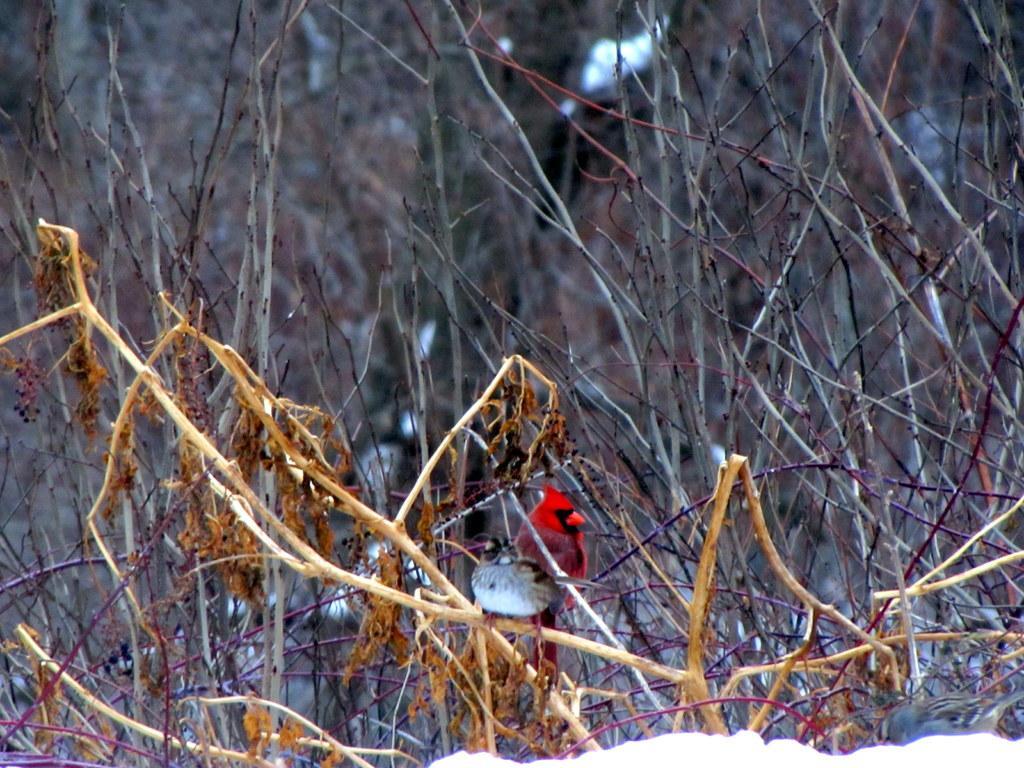Could you give a brief overview of what you see in this image? In this image I can see many sticks. At the bottom, I can see the snow. 